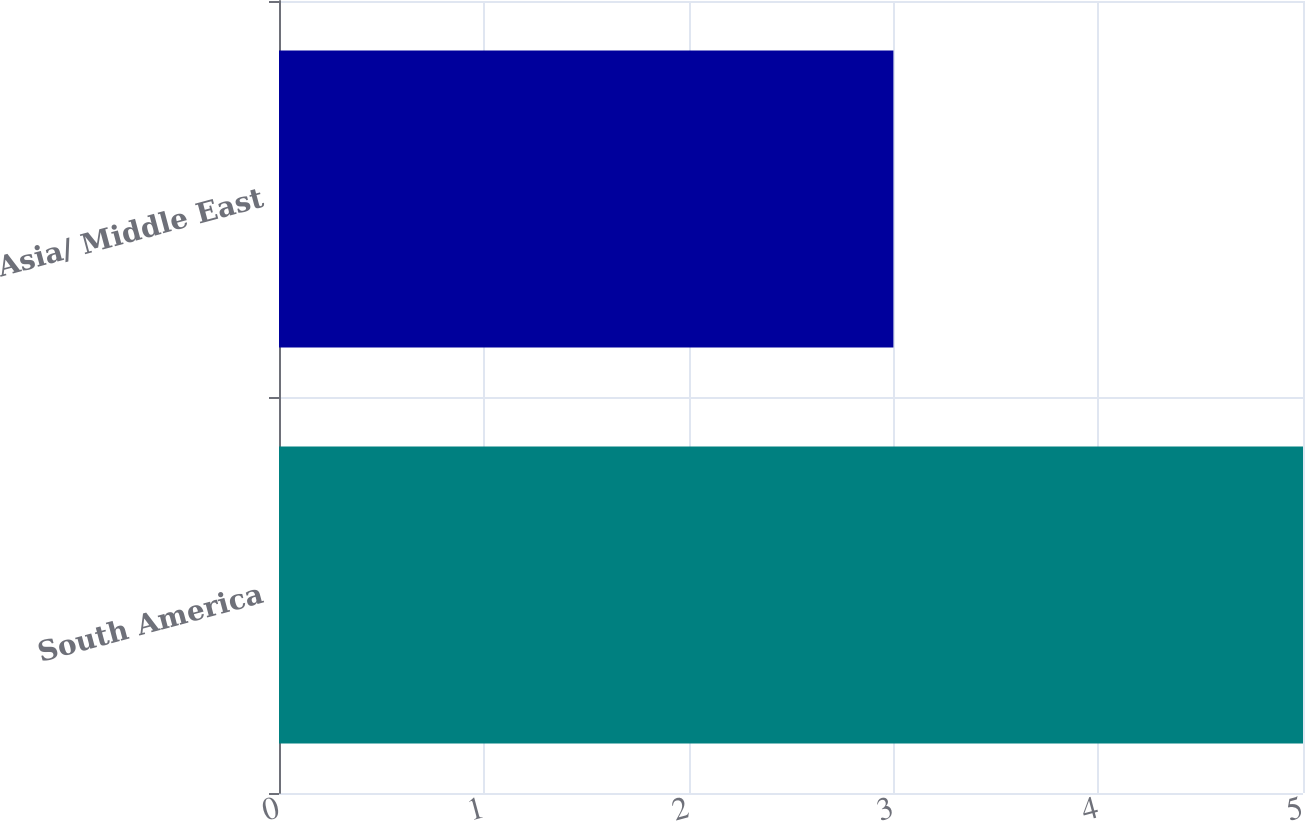Convert chart to OTSL. <chart><loc_0><loc_0><loc_500><loc_500><bar_chart><fcel>South America<fcel>Asia/ Middle East<nl><fcel>5<fcel>3<nl></chart> 